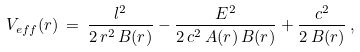Convert formula to latex. <formula><loc_0><loc_0><loc_500><loc_500>V _ { e f f } ( r ) \, = \, \frac { l ^ { 2 } } { 2 \, r ^ { 2 } \, B ( r ) } - \frac { E ^ { 2 } } { 2 \, c ^ { 2 } \, A ( r ) \, B ( r ) } + \frac { c ^ { 2 } } { 2 \, B ( r ) } \, ,</formula> 